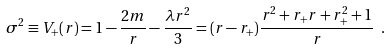<formula> <loc_0><loc_0><loc_500><loc_500>\sigma ^ { 2 } \equiv V _ { + } ( r ) = 1 - \frac { 2 m } { r } - \frac { \lambda r ^ { 2 } } { 3 } = ( r - r _ { + } ) \frac { r ^ { 2 } + r _ { + } r + r _ { + } ^ { 2 } + 1 } { r } \ .</formula> 